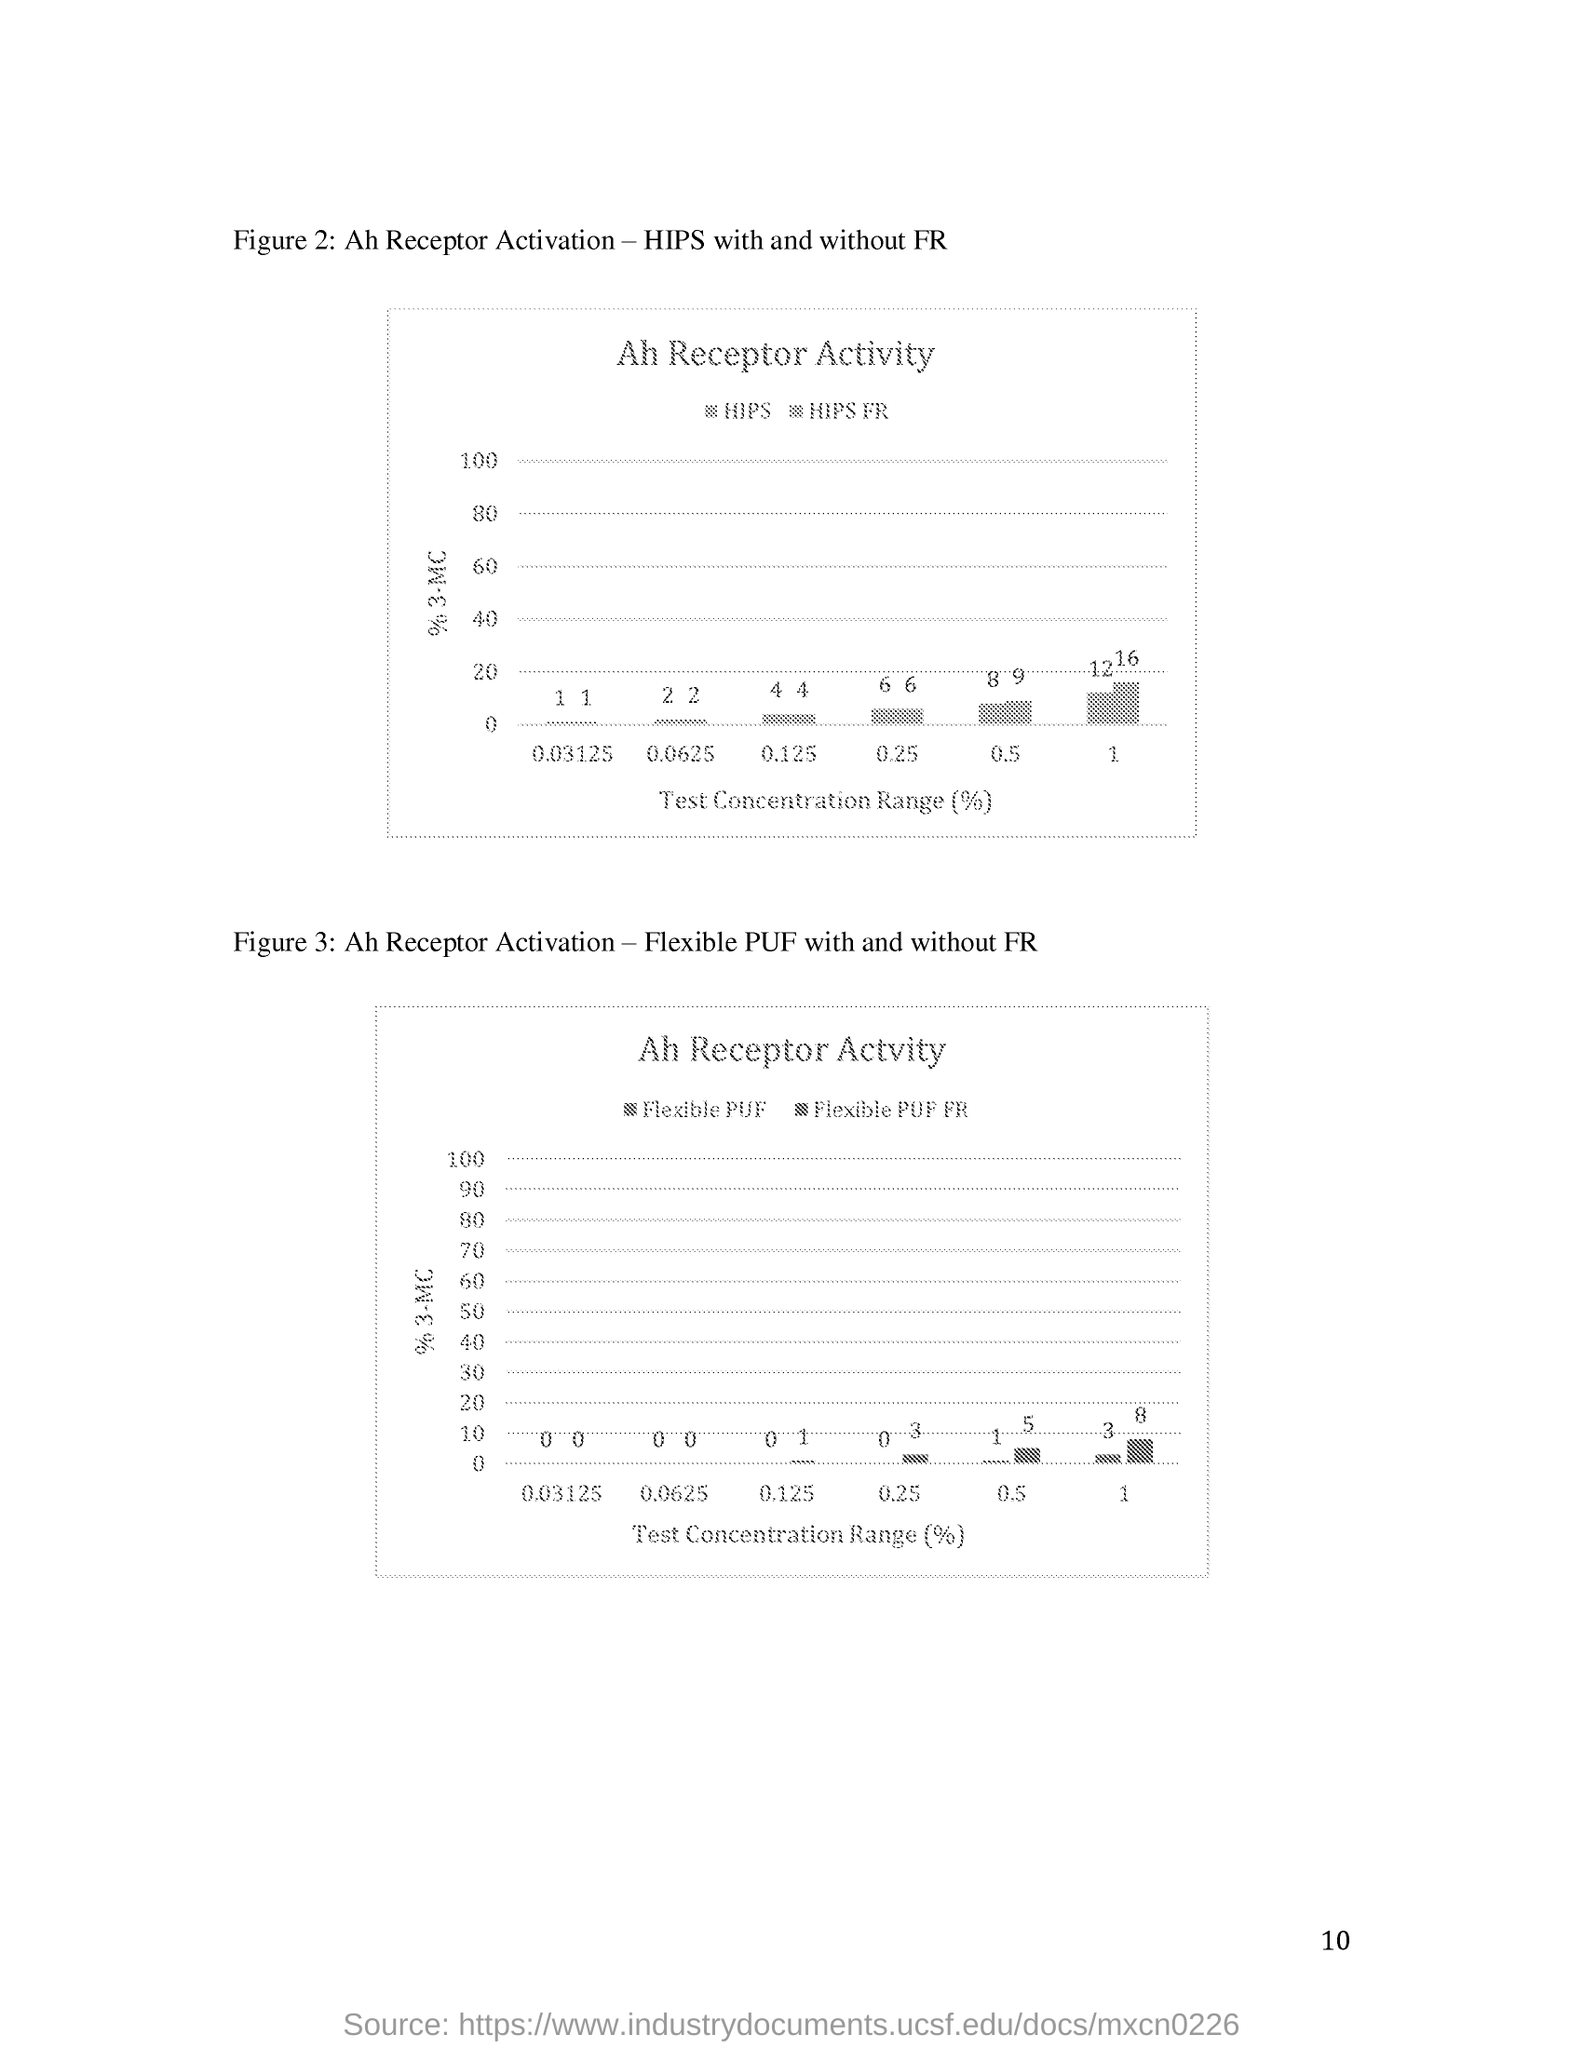Indicate a few pertinent items in this graphic. The page number mentioned in this document is 10. Figure 2 represents the activation of the Ah receptor in the presence and absence of fulvic acid, as demonstrated by the hydrophobic interaction plot (HIPS) and force-field repulsive interaction plot (FR) analyses. 